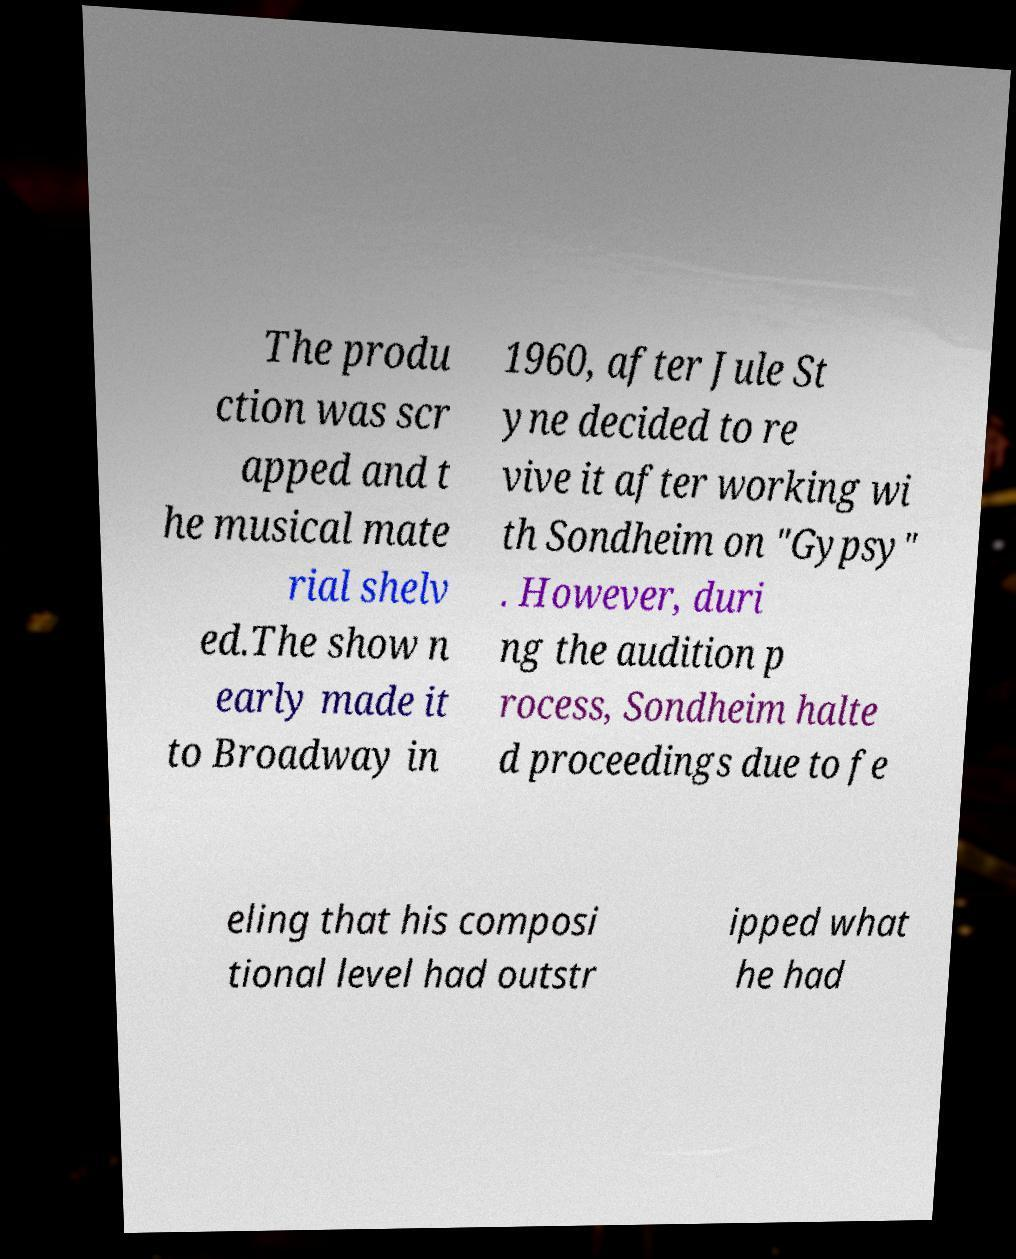Could you extract and type out the text from this image? The produ ction was scr apped and t he musical mate rial shelv ed.The show n early made it to Broadway in 1960, after Jule St yne decided to re vive it after working wi th Sondheim on "Gypsy" . However, duri ng the audition p rocess, Sondheim halte d proceedings due to fe eling that his composi tional level had outstr ipped what he had 